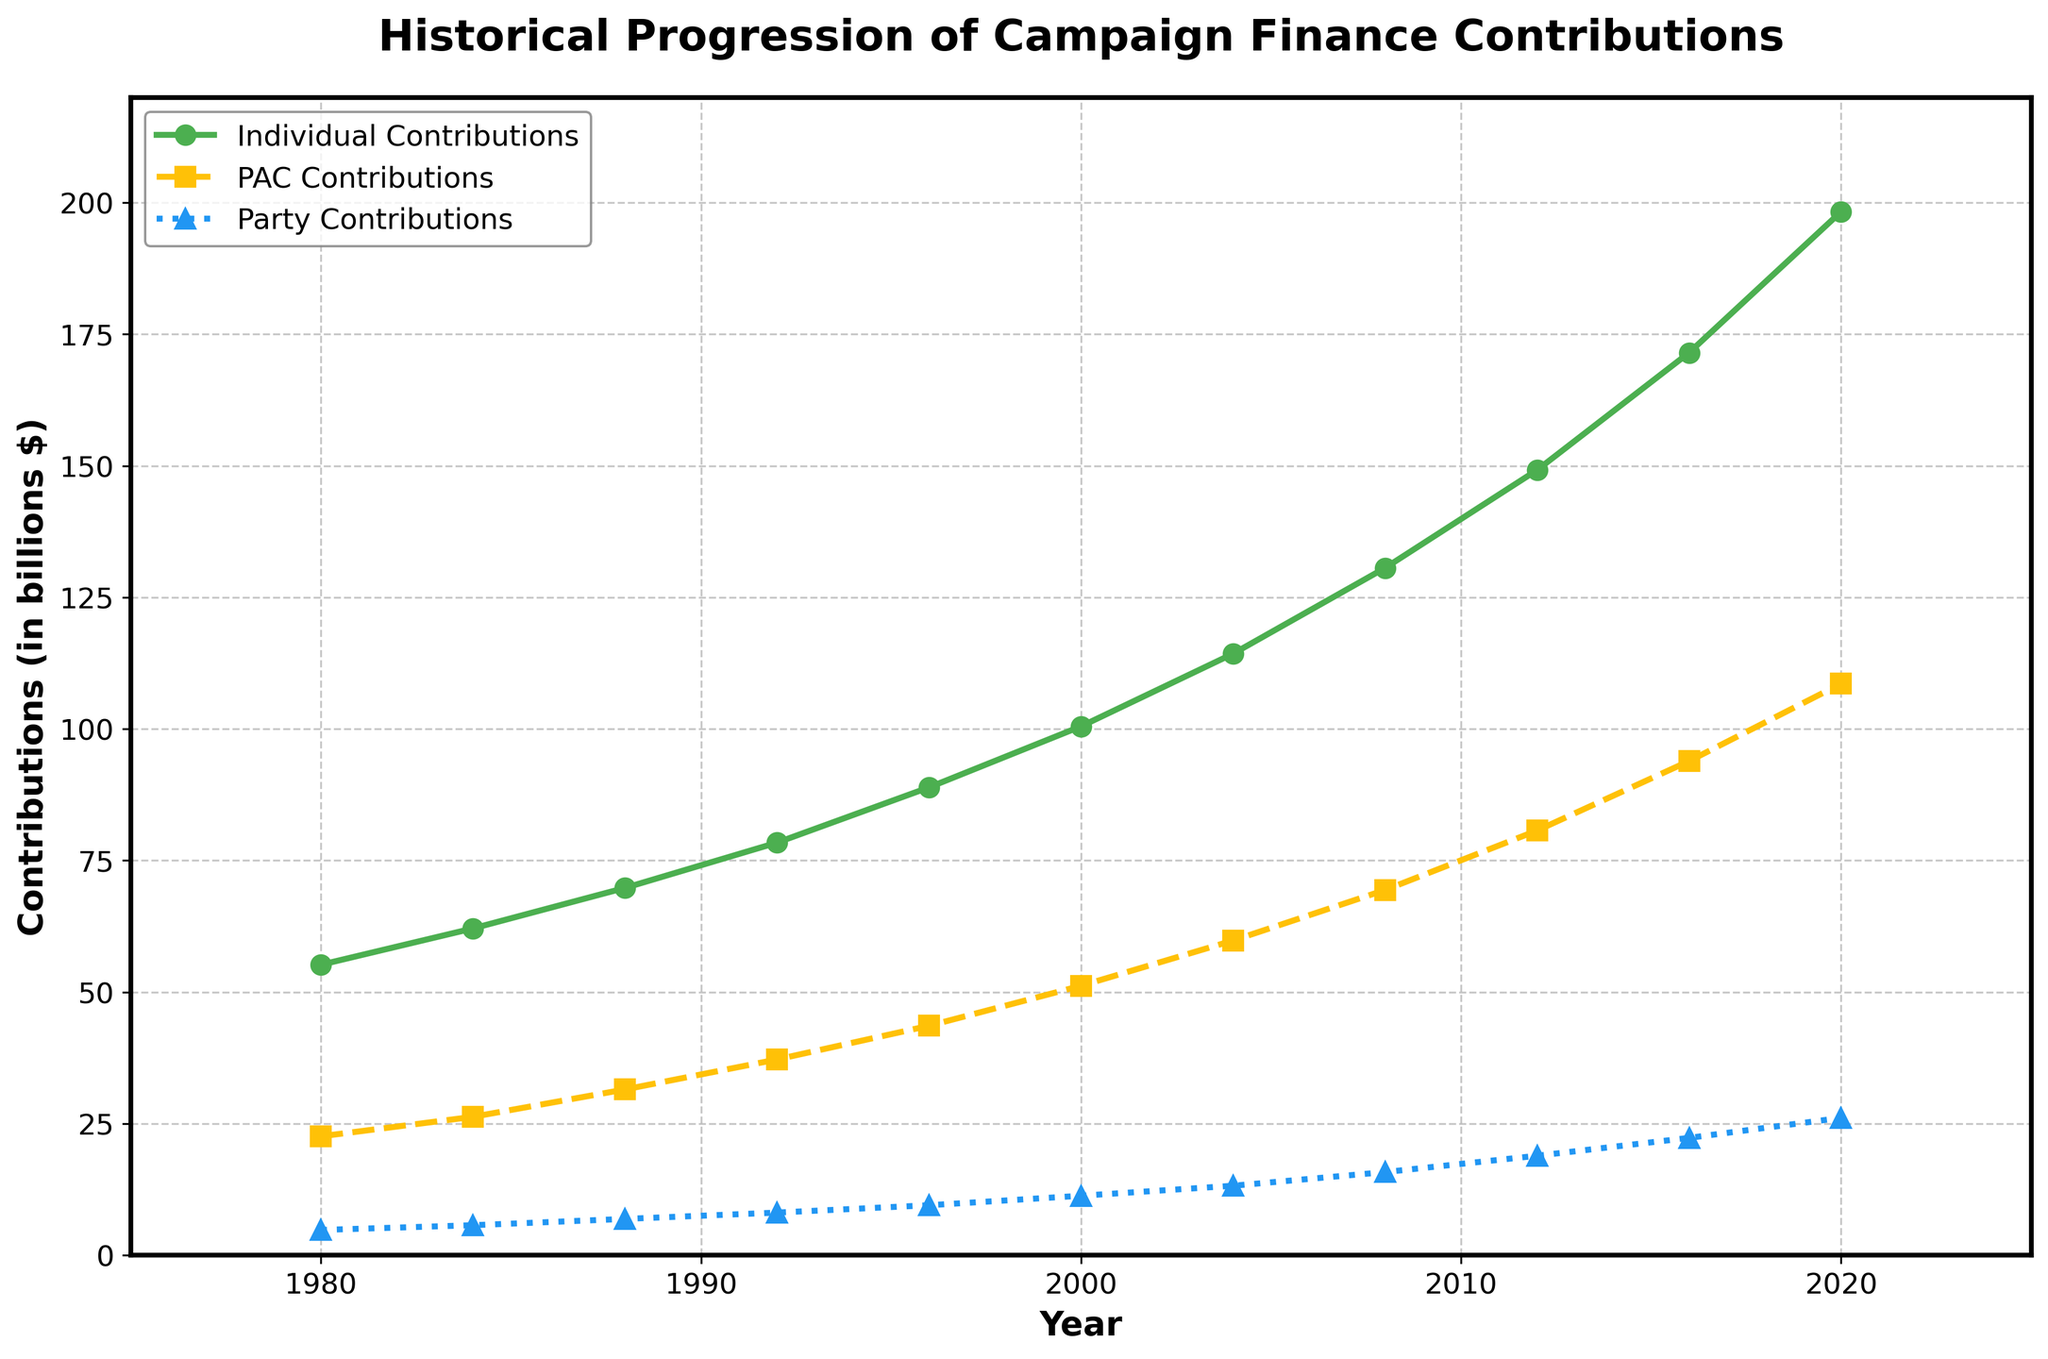What's the overall trend in individual contributions from 1980 to 2020? Observing the line representing individual contributions, we see a consistent upward trend from 1980 to 2020. Each data point is higher than the previous one.
Answer: Increasing Between which years did PAC contributions see the highest increase? By comparing the rises between consecutive years on the PAC contributions line, we can identify the steepest increase. The most significant jump appears between 2016 ($93.9 \text{ billion}$) and 2020 ($108.6 \text{ billion}$).
Answer: 2016 and 2020 What is the total contribution from all sources in 2008? Sum up the contributions in 2008: Individual (\$130.6 \text{ billion}) + PAC (\$69.4 \text{ billion}) + Party (\$15.8 \text{ billion}): $130.6 + 69.4 + 15.8 = 215.8 \text{ billion}$.
Answer: \$215.8 billion Which type of contribution grows at the slowest rate over time? Comparing the slopes of the lines, Party Contributions have the least steep slope, indicating a slower growth rate compared to Individual and PAC contributions.
Answer: Party By how much did individual contributions increase from 1980 to 2020? Subtract the individual contributions in 1980 (\$55.2 \text{ billion}) from those in 2020 (\$198.3 \text{ billion}): $198.3 - 55.2 = 143.1 \text{ billion}$.
Answer: \$143.1 billion At what year did PAC contributions first exceed \$50 billion? The line showing PAC contributions crosses the \$50 \text{ billion}$ mark between 1996 ($43.6 \text{ billion}$) and 2000 ($51.2 \text{ billion}$).
Answer: 2000 Which contribution type has the steepest incline between 2012 and 2016? Visually comparing the lines between 2012 and 2016, Individual Contributions show the steepest incline, moving from $149.2 \text{ billion}$ to $171.5 \text{ billion}$.
Answer: Individual Contributions What is the difference between PAC and Party contributions in 2016? Subtract Party Contributions in 2016 ($22.3 \text{ billion}$) from PAC Contributions in 2016 ($93.9 \text{ billion}$): $93.9 - 22.3 = 71.6 \text{ billion}$.
Answer: \$71.6 billion What is the average annual increase in individual contributions from 1980 to 2020? Calculate the total increase in Individual Contributions: $198.3 - 55.2 = 143.1 \text{ billion}$, then divide by the number of intervals (10 intervals): $143.1 / 10 = 14.31 \text{ billion/year}$.
Answer: \$14.31 billion/year In which decade did party contributions grow the fastest? Comparing the increments by decades, the largest decade-on-decade increases for Party Contributions appear between 2000 ($11.3 \text{ billion}$) and 2010 ($18.9 \text{ billion}$).
Answer: 2000s 